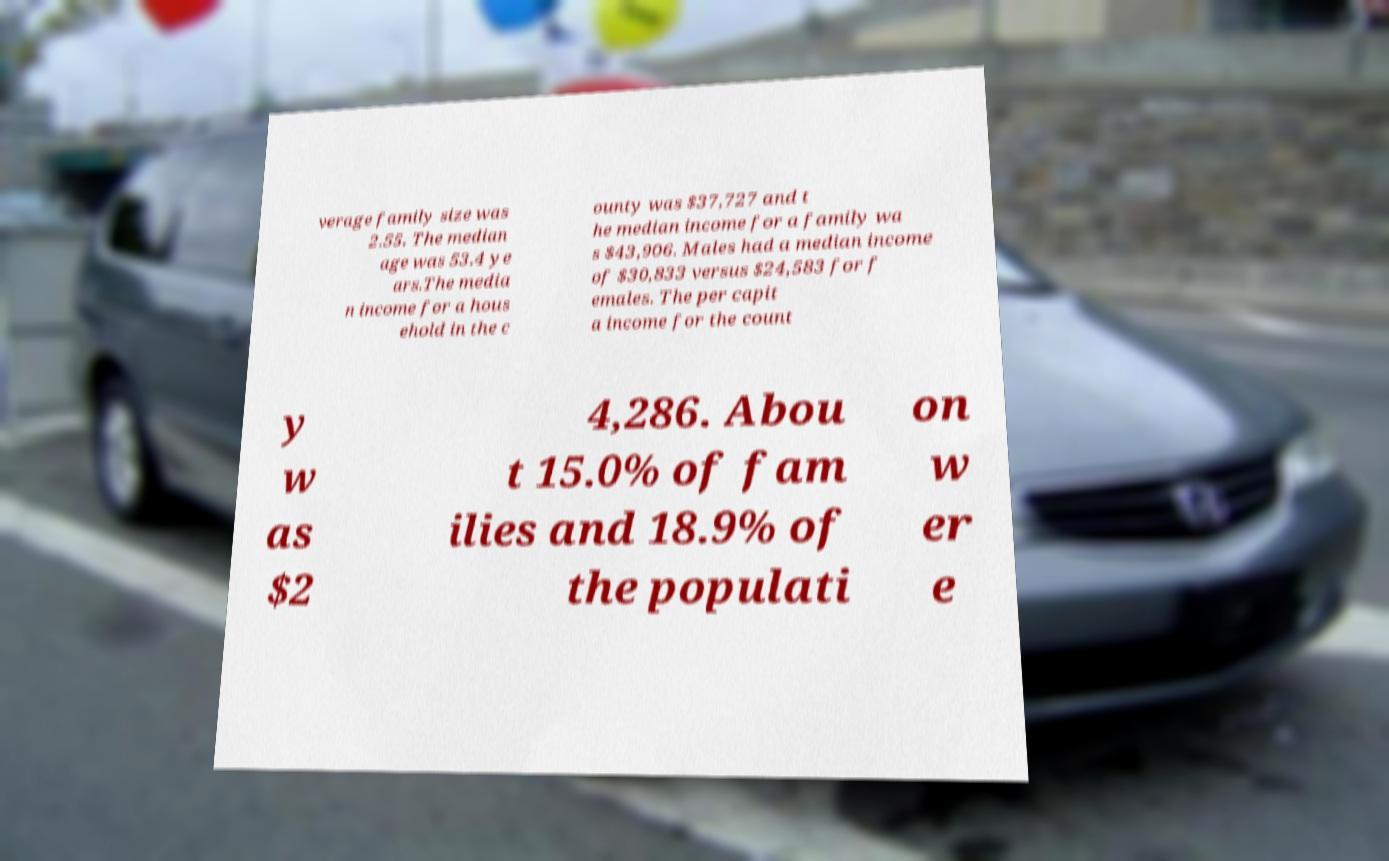What messages or text are displayed in this image? I need them in a readable, typed format. verage family size was 2.55. The median age was 53.4 ye ars.The media n income for a hous ehold in the c ounty was $37,727 and t he median income for a family wa s $43,906. Males had a median income of $30,833 versus $24,583 for f emales. The per capit a income for the count y w as $2 4,286. Abou t 15.0% of fam ilies and 18.9% of the populati on w er e 